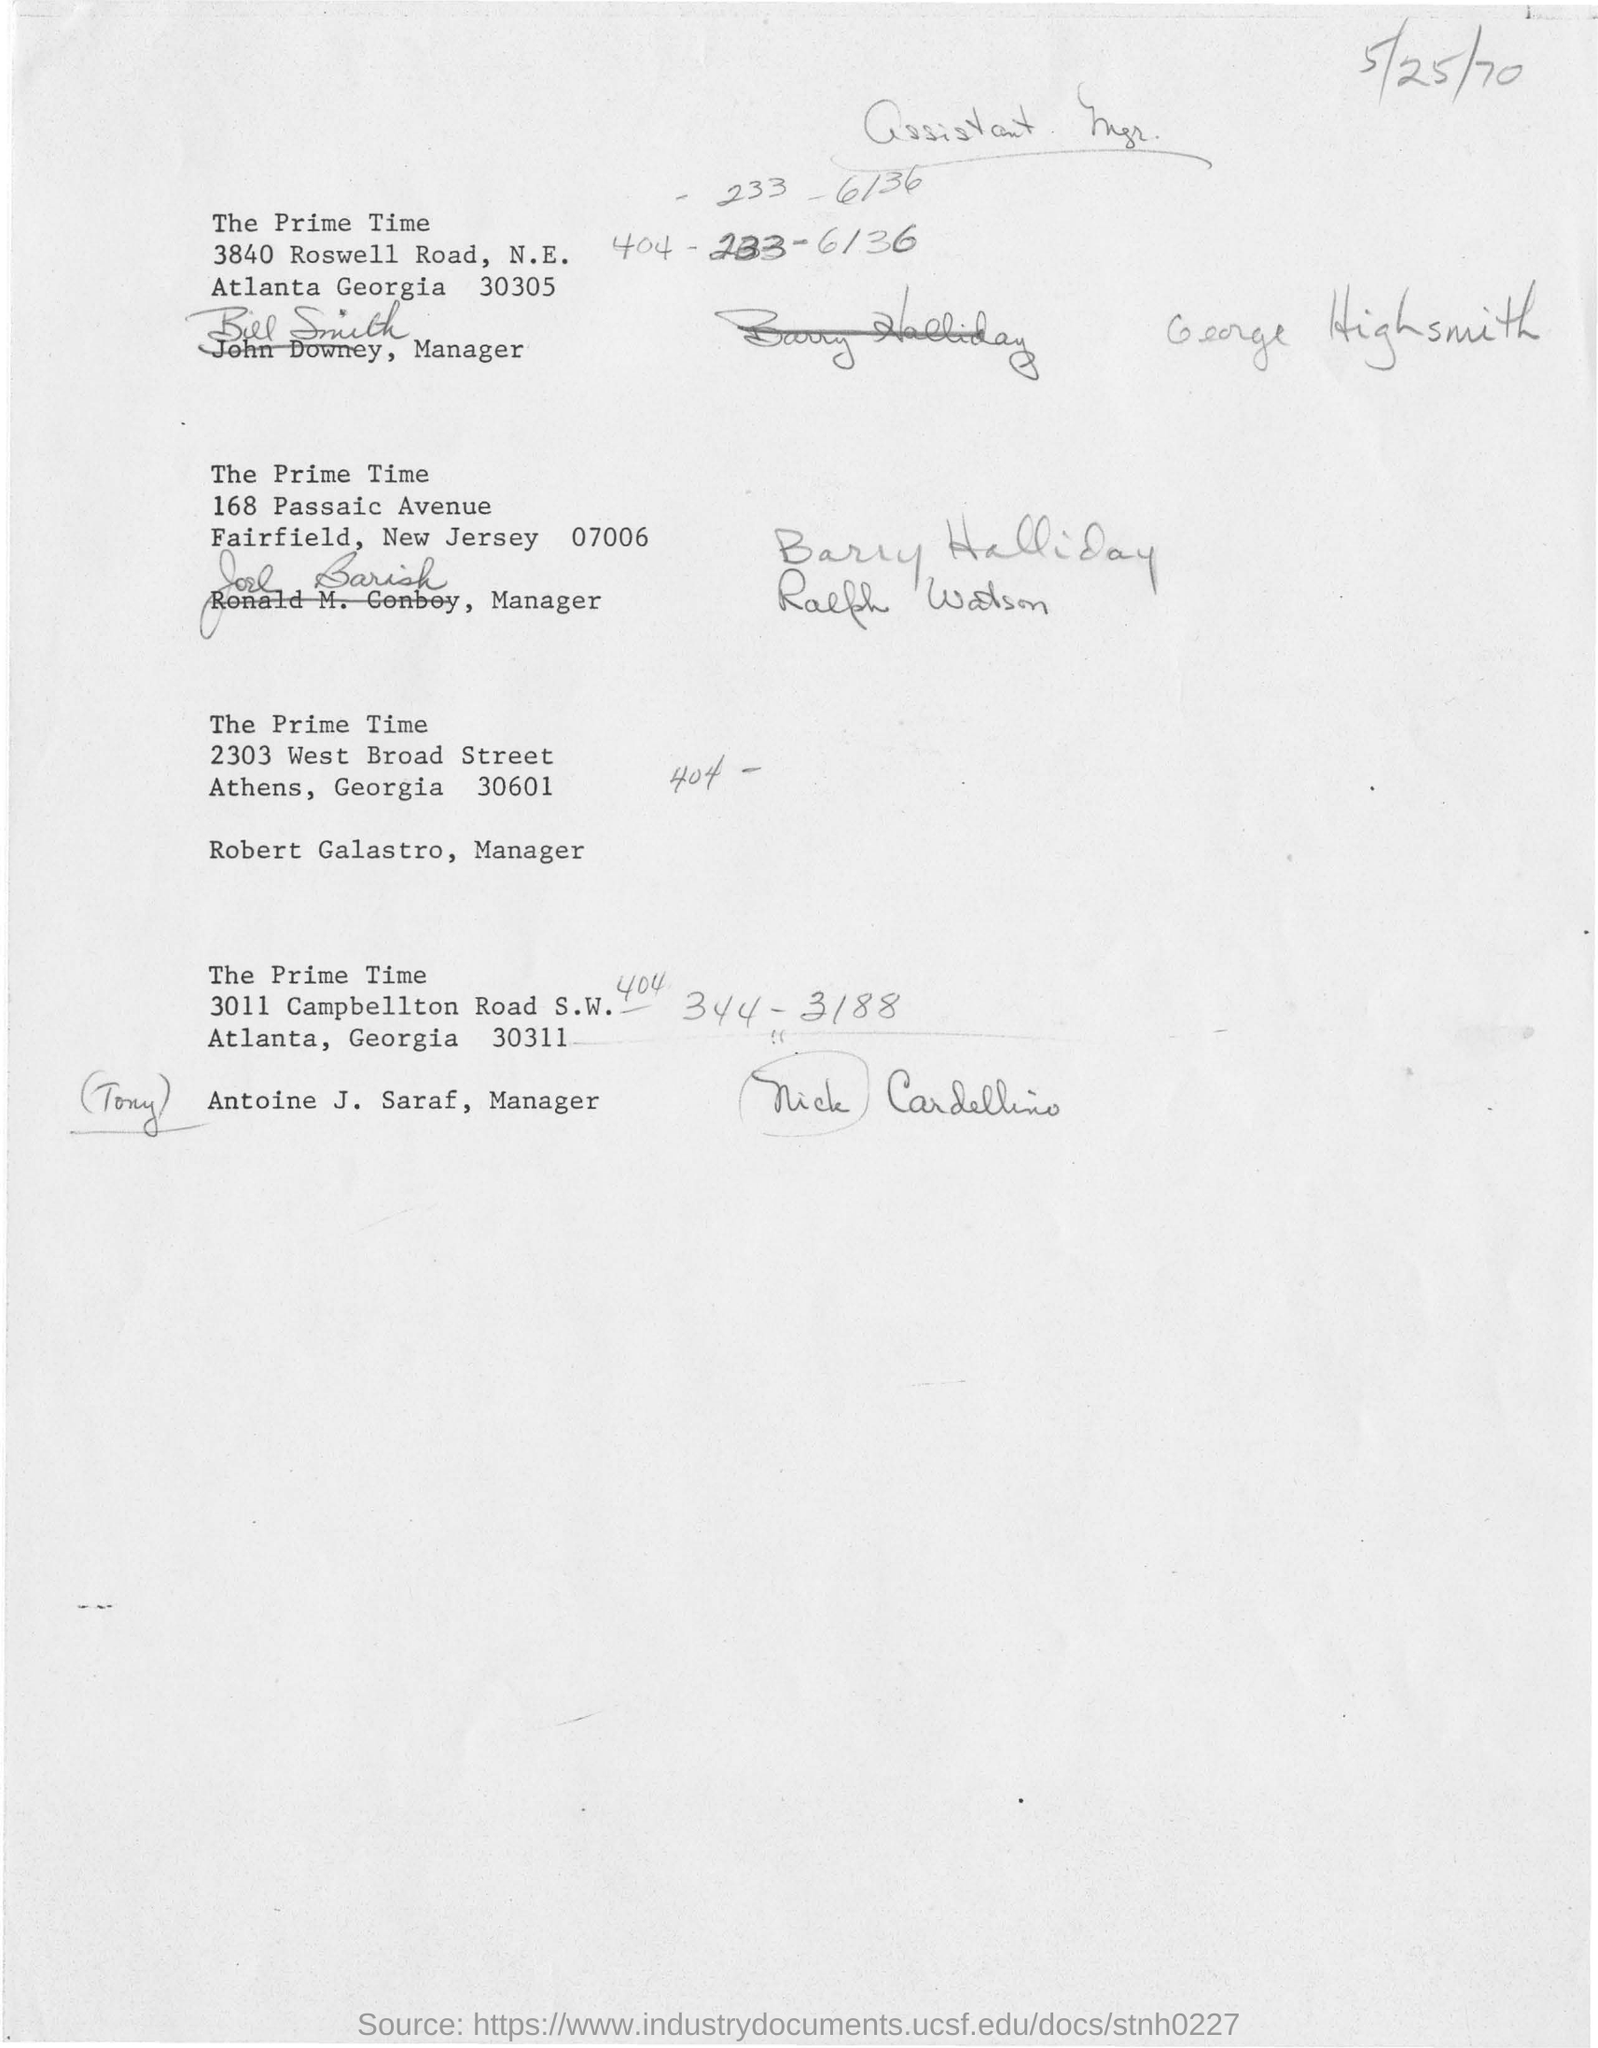In which road "the prime time" is located from the city of atlanta georgia 30305?
Provide a short and direct response. 3840 Roswell Road. In which Avenue" the prime times" is located ?
Keep it short and to the point. 168 Passaic Avenue. Who is the manger from the location of athens, georgia 30601?
Make the answer very short. Robert galastro,. Who is the manager of the prime times from the location of 3011 campbellton road s.w atlanta ,georgia 30311?
Offer a very short reply. Antoine J. Saraf,. What is the date mentioned at the top left side with pencil in the document?
Give a very brief answer. 5/25/70. Who is the manager from the location of 3840 roswell road,n.e. atlanta georgia 30305?
Your answer should be very brief. Bill Smith. 